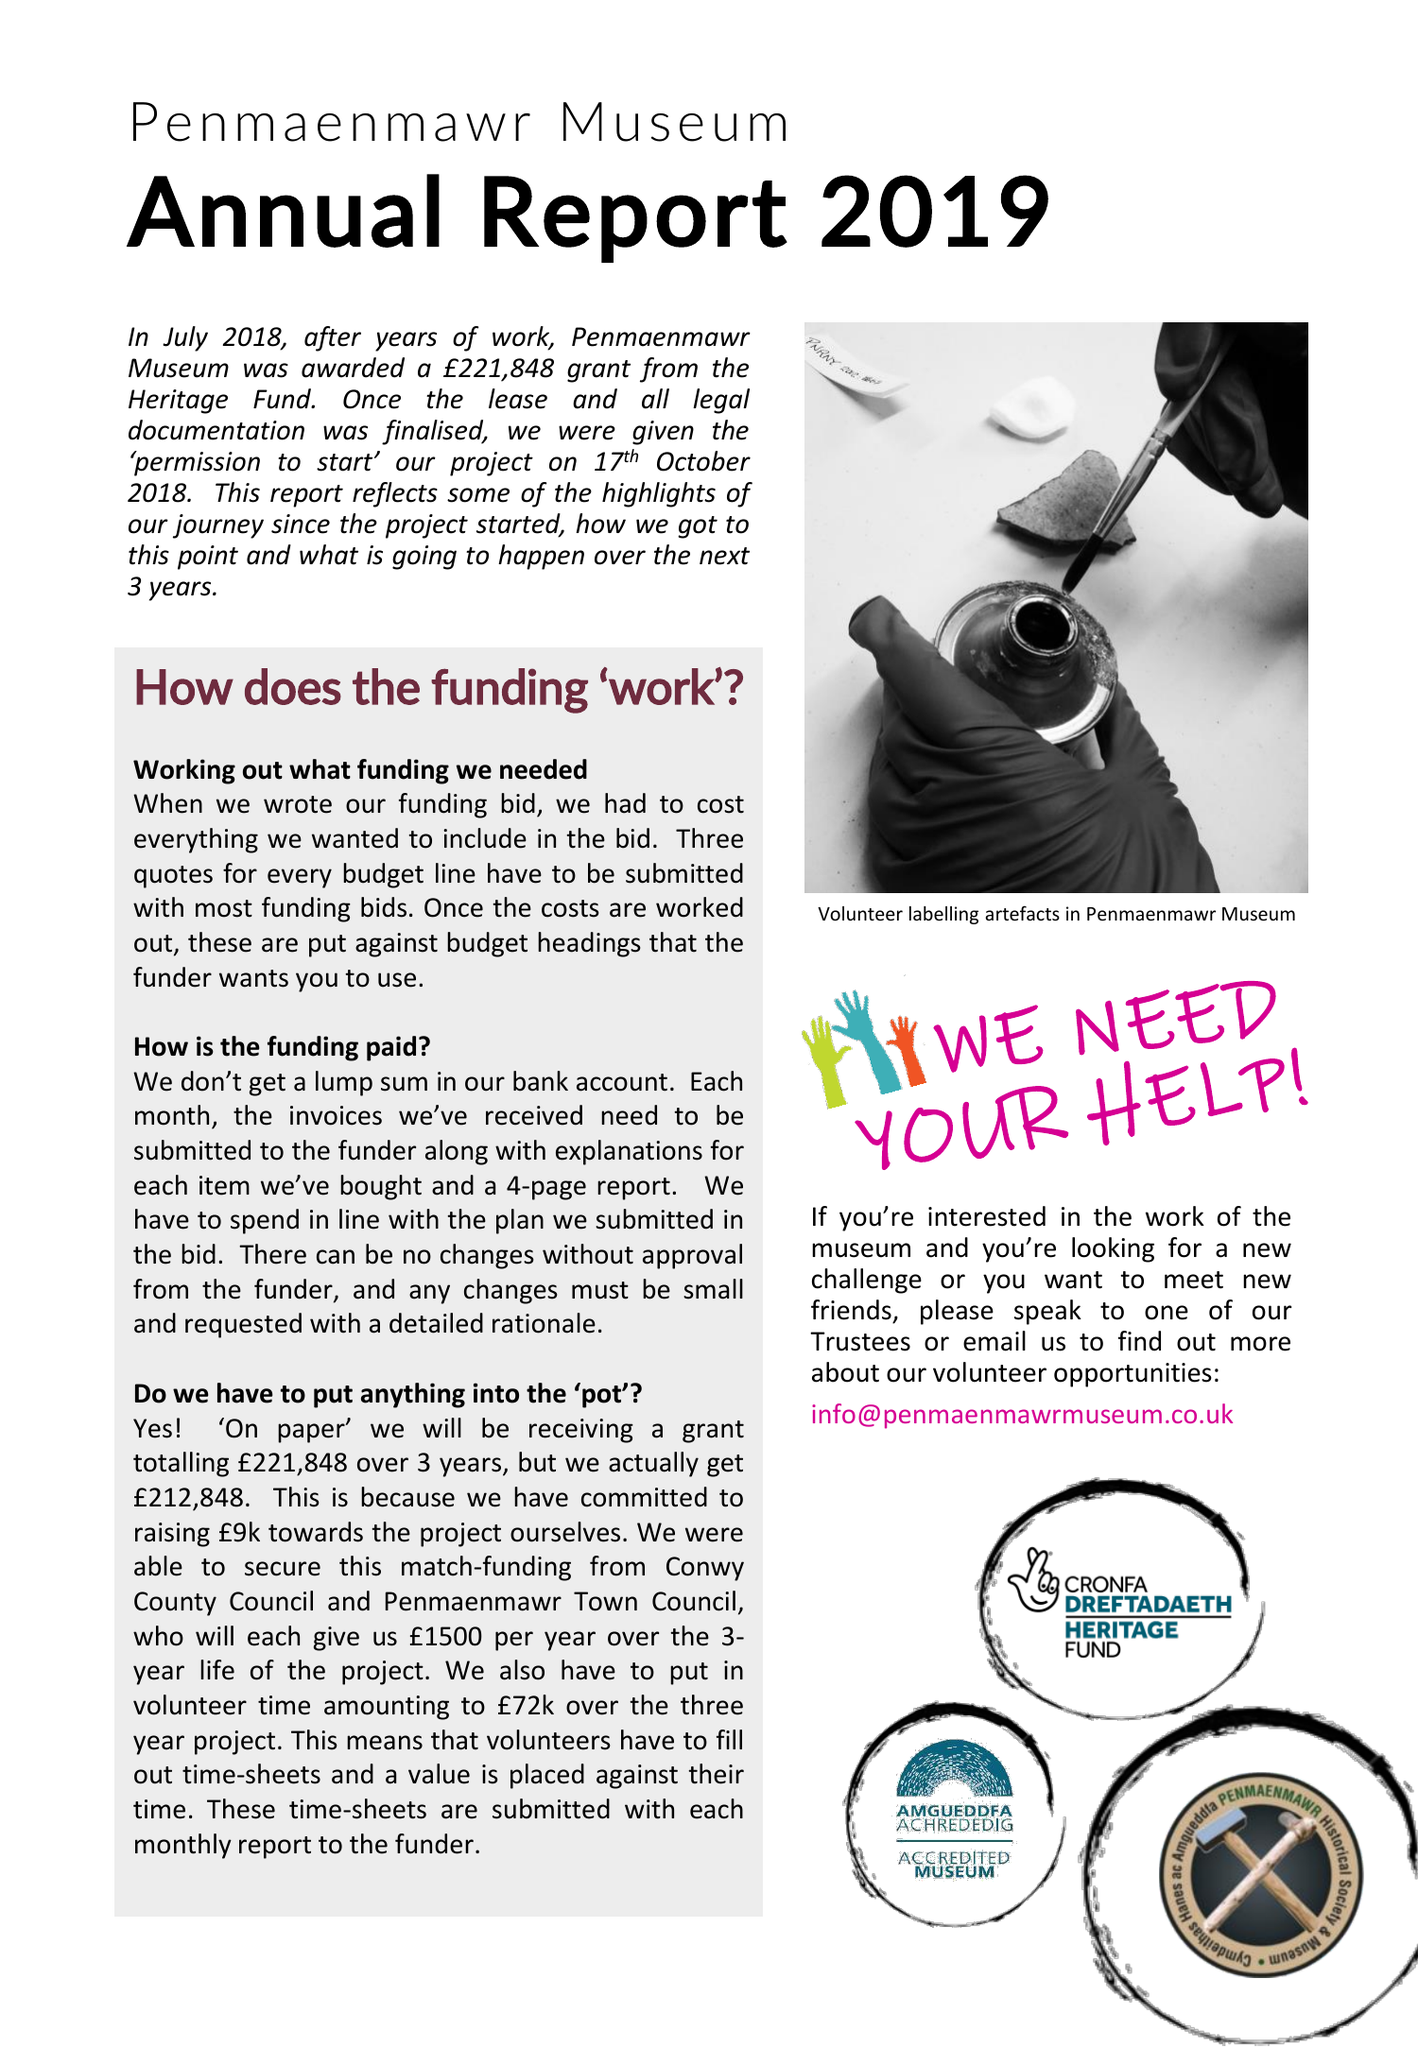What is the value for the address__street_line?
Answer the question using a single word or phrase. None 